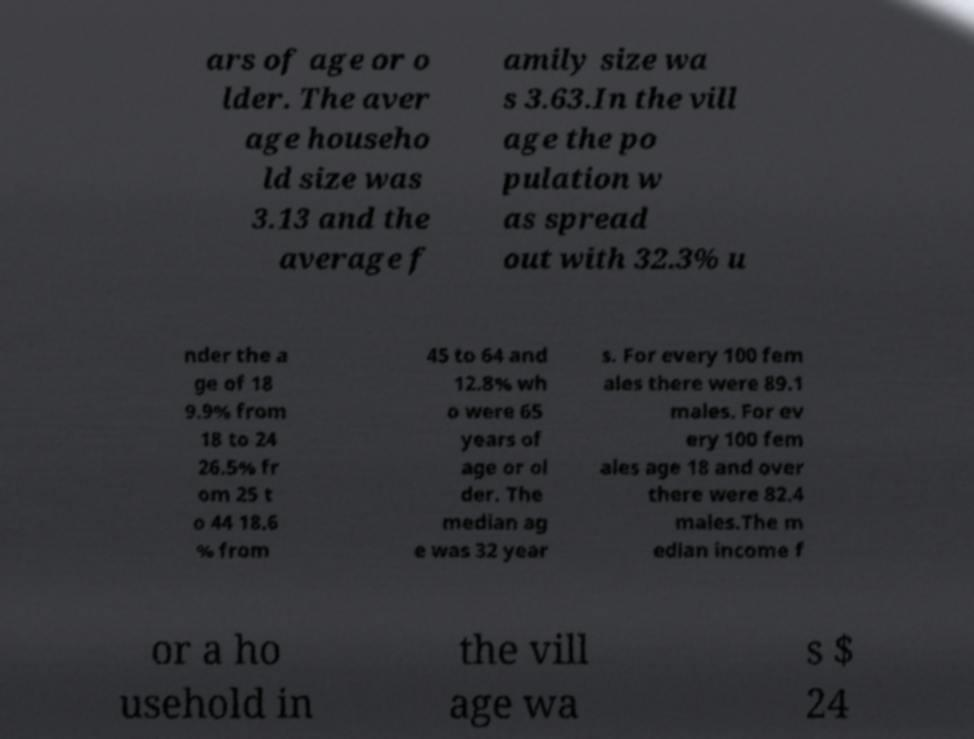Please identify and transcribe the text found in this image. ars of age or o lder. The aver age househo ld size was 3.13 and the average f amily size wa s 3.63.In the vill age the po pulation w as spread out with 32.3% u nder the a ge of 18 9.9% from 18 to 24 26.5% fr om 25 t o 44 18.6 % from 45 to 64 and 12.8% wh o were 65 years of age or ol der. The median ag e was 32 year s. For every 100 fem ales there were 89.1 males. For ev ery 100 fem ales age 18 and over there were 82.4 males.The m edian income f or a ho usehold in the vill age wa s $ 24 